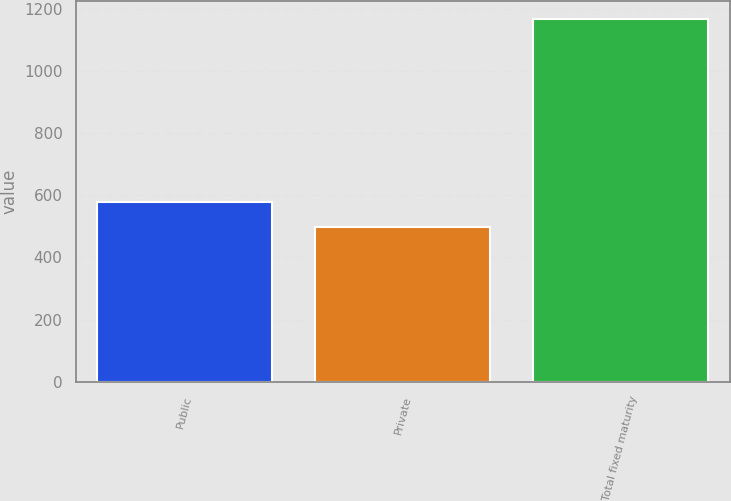Convert chart to OTSL. <chart><loc_0><loc_0><loc_500><loc_500><bar_chart><fcel>Public<fcel>Private<fcel>Total fixed maturity<nl><fcel>577.5<fcel>496.3<fcel>1168.2<nl></chart> 